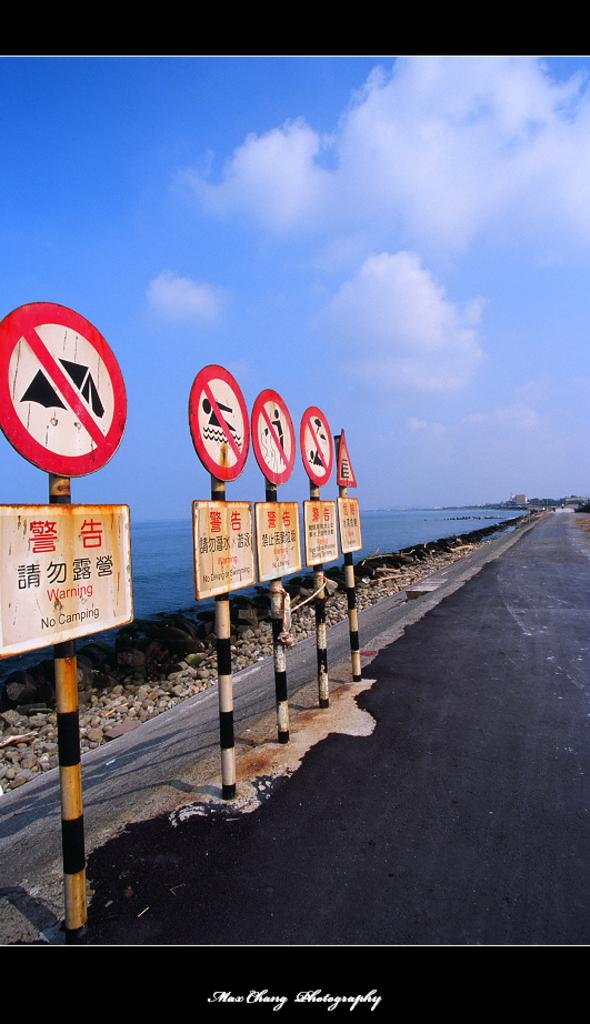<image>
Describe the image concisely. The first sign on the left is giving a no camping warning. 